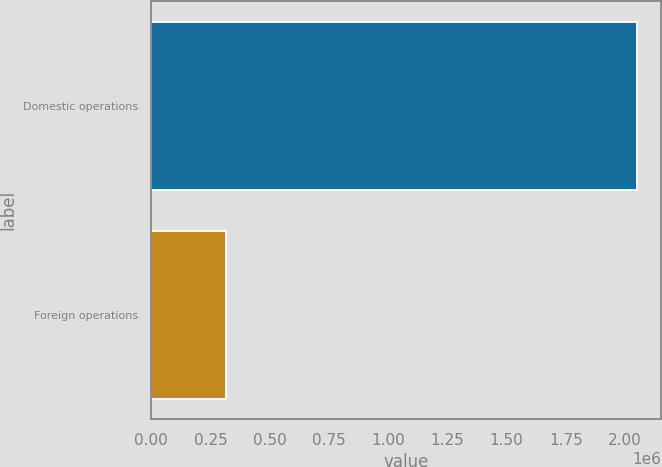<chart> <loc_0><loc_0><loc_500><loc_500><bar_chart><fcel>Domestic operations<fcel>Foreign operations<nl><fcel>2.04887e+06<fcel>314655<nl></chart> 